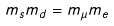Convert formula to latex. <formula><loc_0><loc_0><loc_500><loc_500>m _ { s } m _ { d } = m _ { \mu } m _ { e }</formula> 